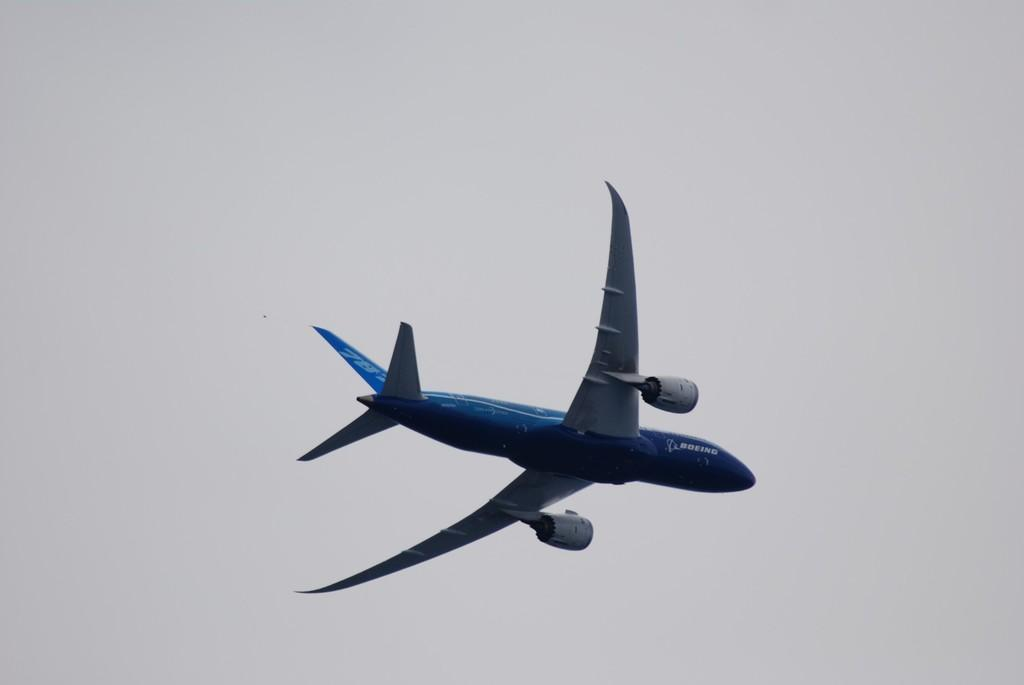What is the main subject of the image? The main subject of the image is an airplane. What color is the airplane in the image? The airplane is in blue color. What can be seen in the background of the image? The sky is visible in the background of the image. What type of kitten can be seen playing with a blade in the image? There is no kitten or blade present in the image, and therefore no such activity can be observed. 